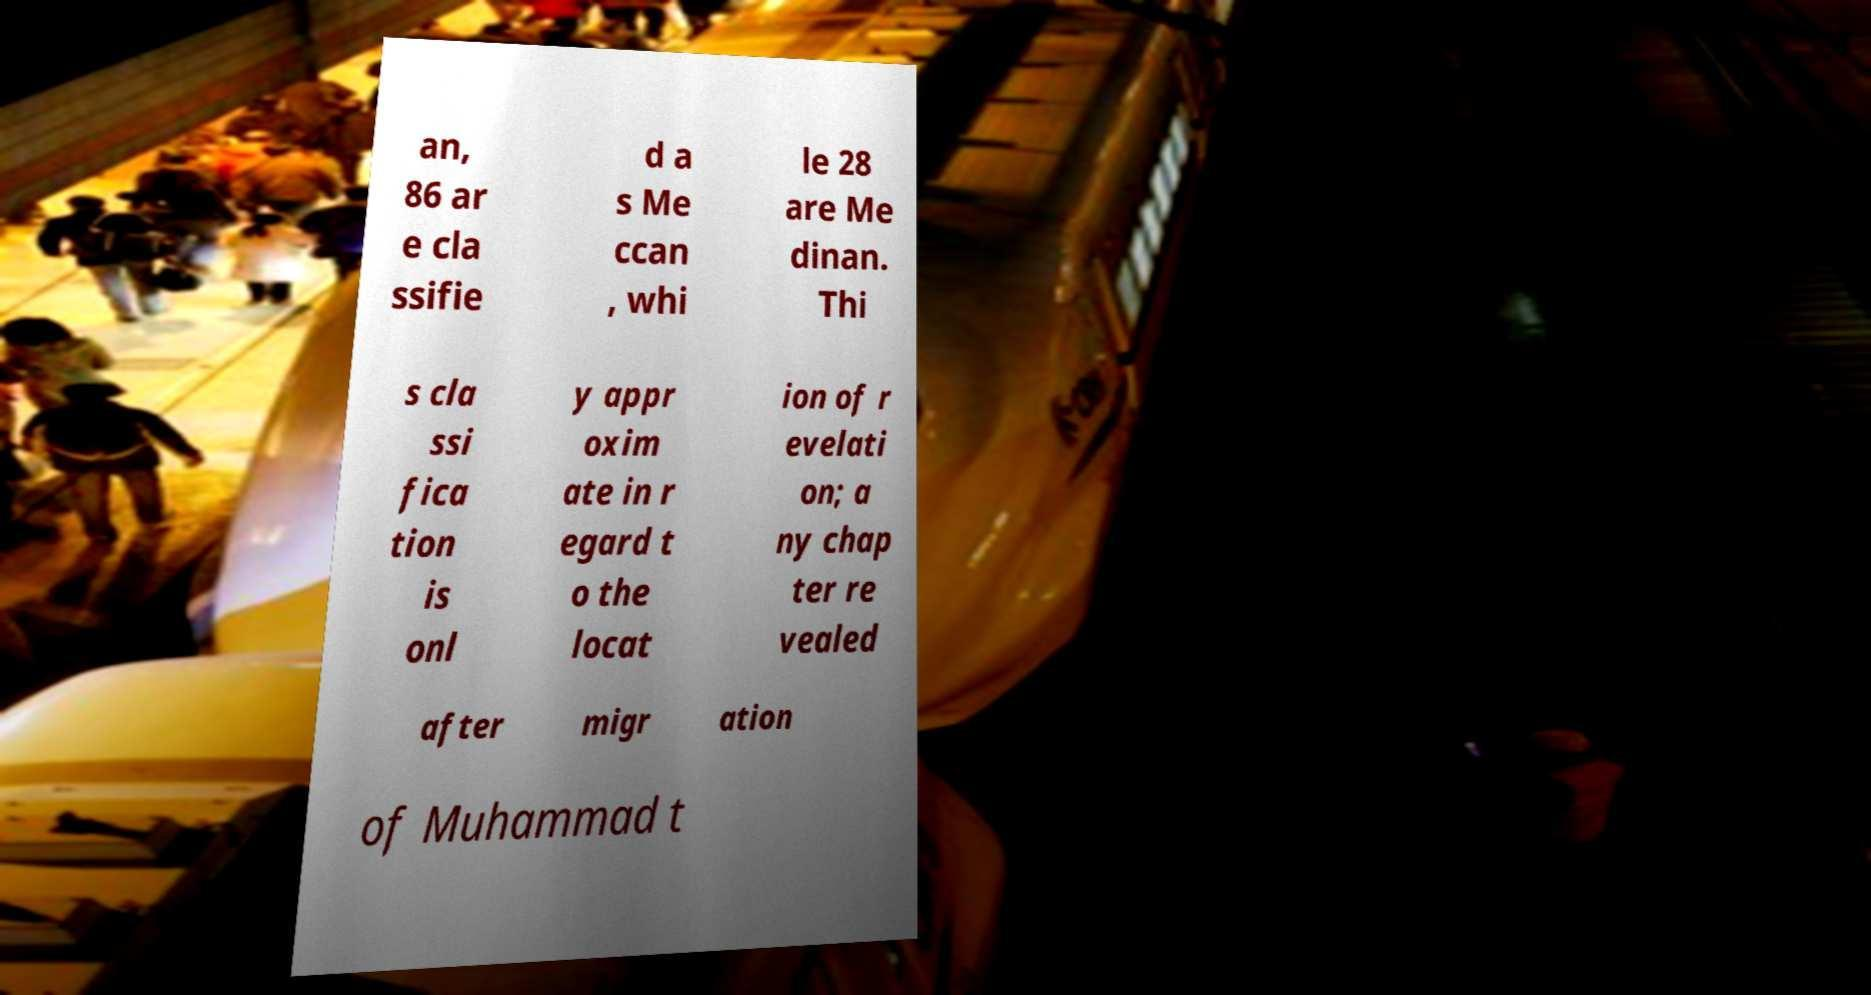Could you extract and type out the text from this image? an, 86 ar e cla ssifie d a s Me ccan , whi le 28 are Me dinan. Thi s cla ssi fica tion is onl y appr oxim ate in r egard t o the locat ion of r evelati on; a ny chap ter re vealed after migr ation of Muhammad t 